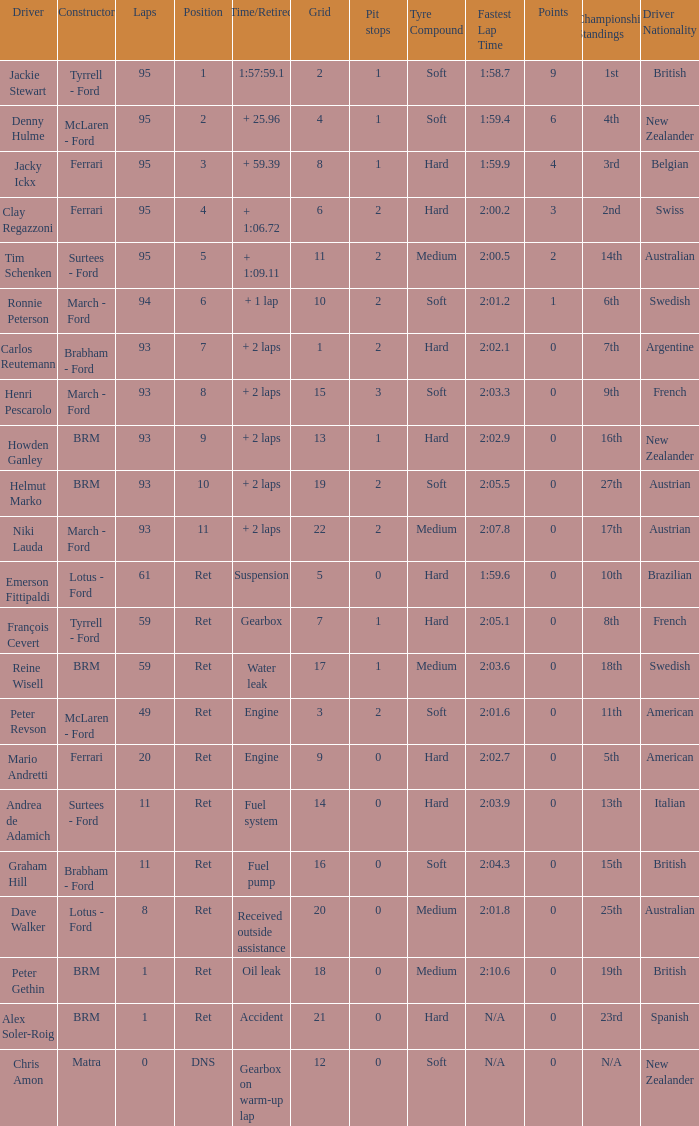What is the total number of grids for peter gethin? 18.0. 